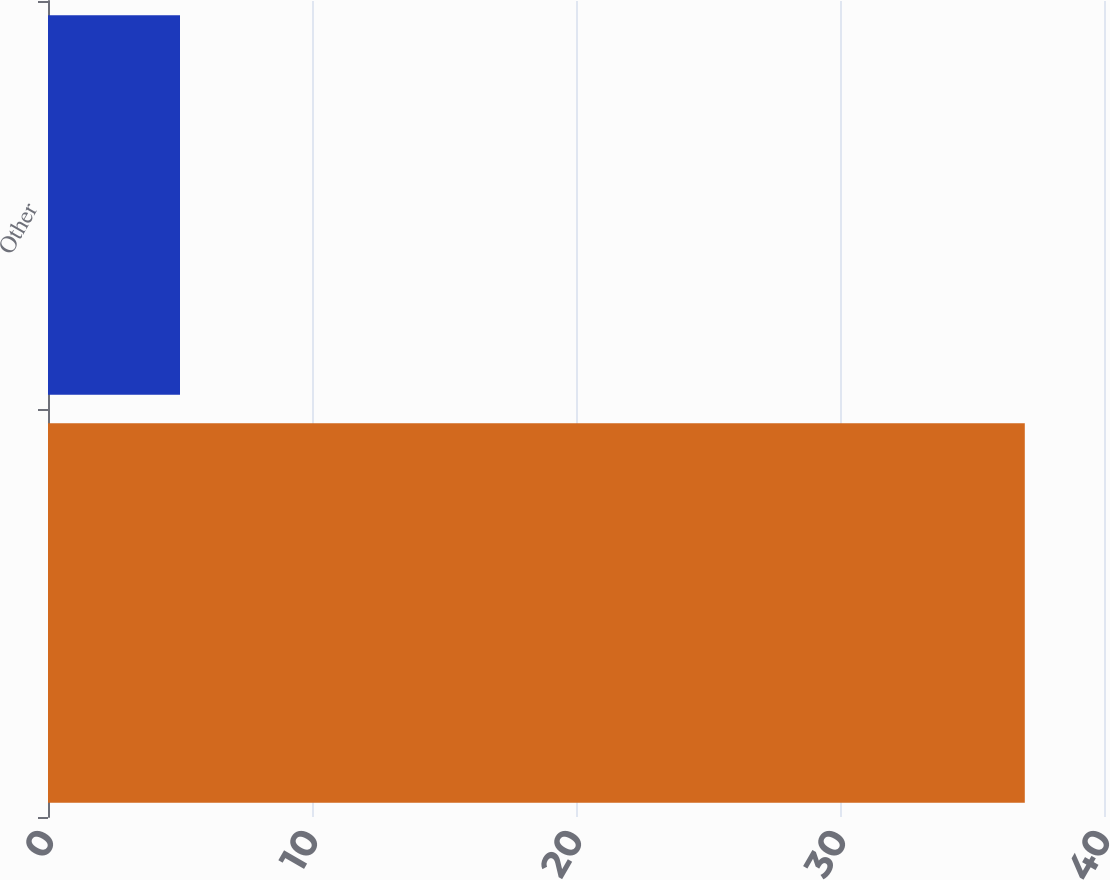Convert chart. <chart><loc_0><loc_0><loc_500><loc_500><bar_chart><ecel><fcel>Other<nl><fcel>37<fcel>5<nl></chart> 